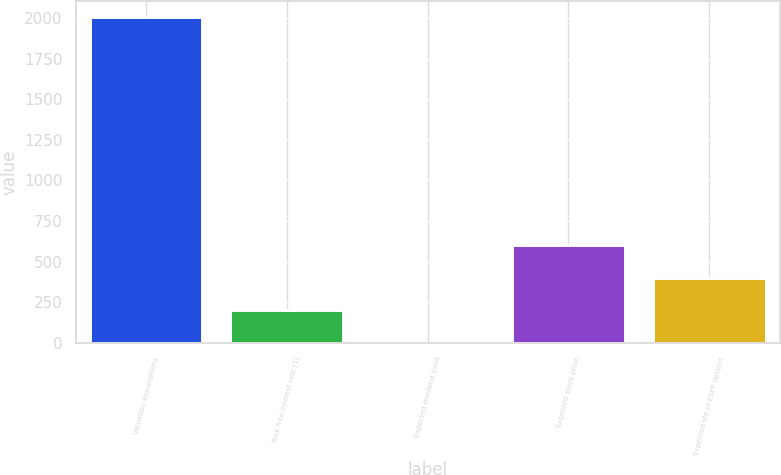Convert chart. <chart><loc_0><loc_0><loc_500><loc_500><bar_chart><fcel>Valuation Assumptions<fcel>Risk-free interest rate (1)<fcel>Expected dividend yield<fcel>Expected stock price<fcel>Expected life of ESPP options<nl><fcel>2006<fcel>201.32<fcel>0.8<fcel>602.36<fcel>401.84<nl></chart> 